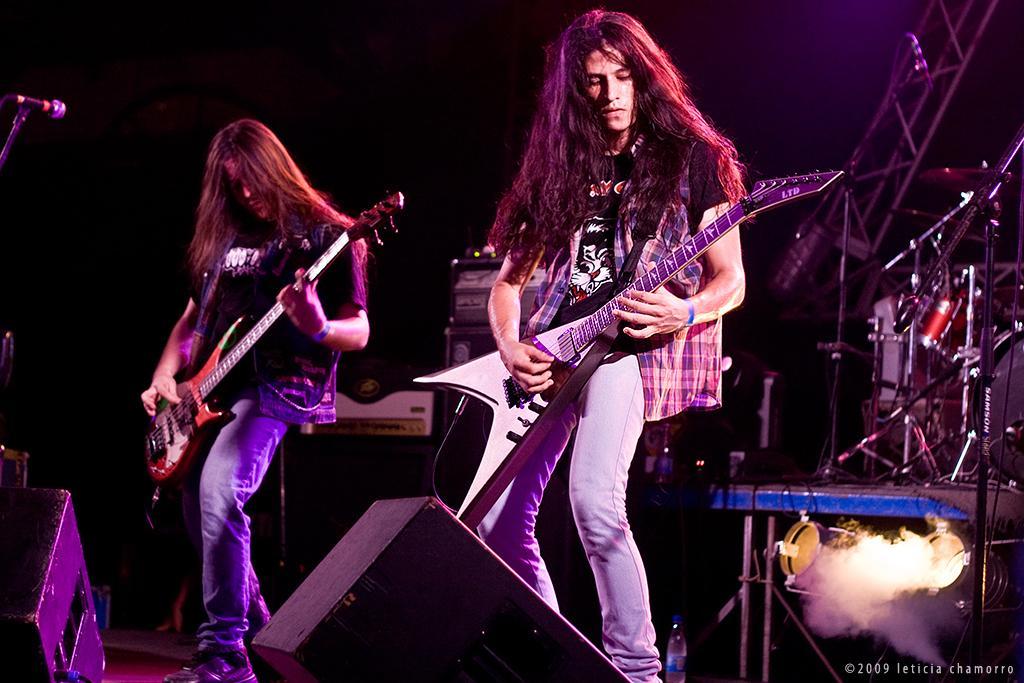Please provide a concise description of this image. This image consists of two persons playing guitars. It looks like a concert. At the bottom, there are speakers. To the right, there are stands. To the left, there is a mic. The background is dark. 